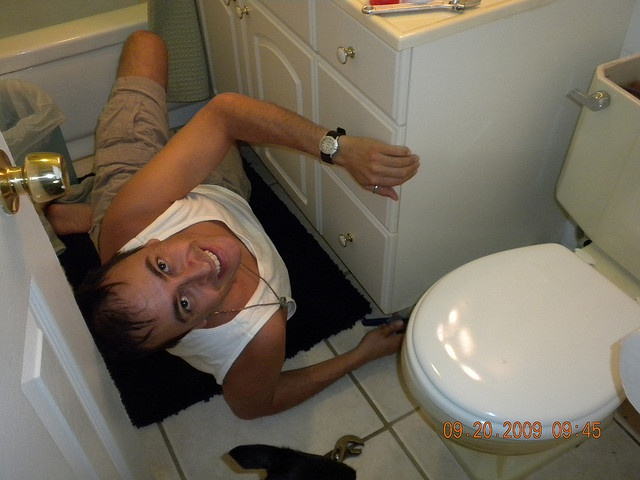Describe the objects in this image and their specific colors. I can see people in gray, maroon, black, and brown tones and toilet in gray, darkgray, and lightgray tones in this image. 